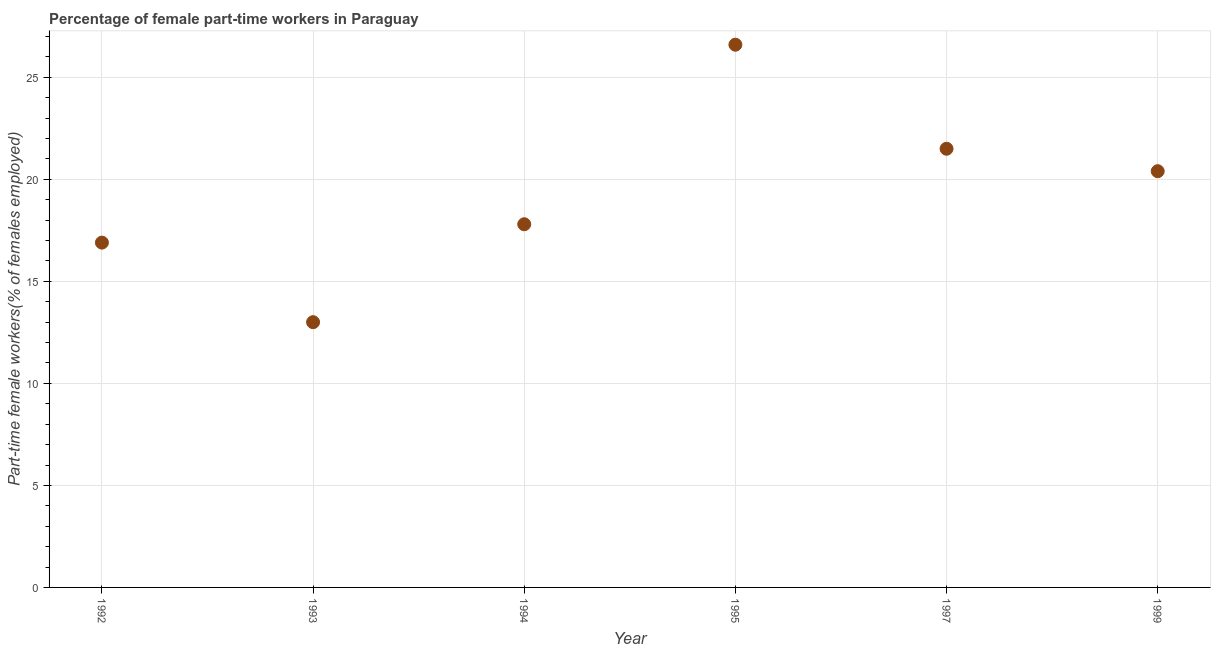What is the percentage of part-time female workers in 1997?
Provide a succinct answer. 21.5. Across all years, what is the maximum percentage of part-time female workers?
Offer a very short reply. 26.6. What is the sum of the percentage of part-time female workers?
Give a very brief answer. 116.2. What is the difference between the percentage of part-time female workers in 1995 and 1997?
Give a very brief answer. 5.1. What is the average percentage of part-time female workers per year?
Give a very brief answer. 19.37. What is the median percentage of part-time female workers?
Offer a terse response. 19.1. What is the ratio of the percentage of part-time female workers in 1995 to that in 1997?
Your response must be concise. 1.24. Is the percentage of part-time female workers in 1993 less than that in 1997?
Keep it short and to the point. Yes. What is the difference between the highest and the second highest percentage of part-time female workers?
Give a very brief answer. 5.1. What is the difference between the highest and the lowest percentage of part-time female workers?
Ensure brevity in your answer.  13.6. Does the percentage of part-time female workers monotonically increase over the years?
Provide a succinct answer. No. How many years are there in the graph?
Offer a terse response. 6. Are the values on the major ticks of Y-axis written in scientific E-notation?
Give a very brief answer. No. Does the graph contain any zero values?
Offer a very short reply. No. Does the graph contain grids?
Your answer should be very brief. Yes. What is the title of the graph?
Make the answer very short. Percentage of female part-time workers in Paraguay. What is the label or title of the X-axis?
Your answer should be compact. Year. What is the label or title of the Y-axis?
Your answer should be very brief. Part-time female workers(% of females employed). What is the Part-time female workers(% of females employed) in 1992?
Your answer should be very brief. 16.9. What is the Part-time female workers(% of females employed) in 1993?
Make the answer very short. 13. What is the Part-time female workers(% of females employed) in 1994?
Ensure brevity in your answer.  17.8. What is the Part-time female workers(% of females employed) in 1995?
Offer a very short reply. 26.6. What is the Part-time female workers(% of females employed) in 1999?
Offer a very short reply. 20.4. What is the difference between the Part-time female workers(% of females employed) in 1992 and 1993?
Your response must be concise. 3.9. What is the difference between the Part-time female workers(% of females employed) in 1992 and 1995?
Give a very brief answer. -9.7. What is the difference between the Part-time female workers(% of females employed) in 1992 and 1997?
Offer a very short reply. -4.6. What is the difference between the Part-time female workers(% of females employed) in 1993 and 1994?
Provide a succinct answer. -4.8. What is the difference between the Part-time female workers(% of females employed) in 1993 and 1995?
Your answer should be compact. -13.6. What is the difference between the Part-time female workers(% of females employed) in 1994 and 1995?
Provide a short and direct response. -8.8. What is the difference between the Part-time female workers(% of females employed) in 1994 and 1997?
Your answer should be very brief. -3.7. What is the ratio of the Part-time female workers(% of females employed) in 1992 to that in 1993?
Give a very brief answer. 1.3. What is the ratio of the Part-time female workers(% of females employed) in 1992 to that in 1994?
Offer a very short reply. 0.95. What is the ratio of the Part-time female workers(% of females employed) in 1992 to that in 1995?
Offer a very short reply. 0.64. What is the ratio of the Part-time female workers(% of females employed) in 1992 to that in 1997?
Ensure brevity in your answer.  0.79. What is the ratio of the Part-time female workers(% of females employed) in 1992 to that in 1999?
Keep it short and to the point. 0.83. What is the ratio of the Part-time female workers(% of females employed) in 1993 to that in 1994?
Your answer should be very brief. 0.73. What is the ratio of the Part-time female workers(% of females employed) in 1993 to that in 1995?
Keep it short and to the point. 0.49. What is the ratio of the Part-time female workers(% of females employed) in 1993 to that in 1997?
Your answer should be compact. 0.6. What is the ratio of the Part-time female workers(% of females employed) in 1993 to that in 1999?
Your answer should be very brief. 0.64. What is the ratio of the Part-time female workers(% of females employed) in 1994 to that in 1995?
Provide a succinct answer. 0.67. What is the ratio of the Part-time female workers(% of females employed) in 1994 to that in 1997?
Provide a succinct answer. 0.83. What is the ratio of the Part-time female workers(% of females employed) in 1994 to that in 1999?
Give a very brief answer. 0.87. What is the ratio of the Part-time female workers(% of females employed) in 1995 to that in 1997?
Your answer should be compact. 1.24. What is the ratio of the Part-time female workers(% of females employed) in 1995 to that in 1999?
Your response must be concise. 1.3. What is the ratio of the Part-time female workers(% of females employed) in 1997 to that in 1999?
Keep it short and to the point. 1.05. 